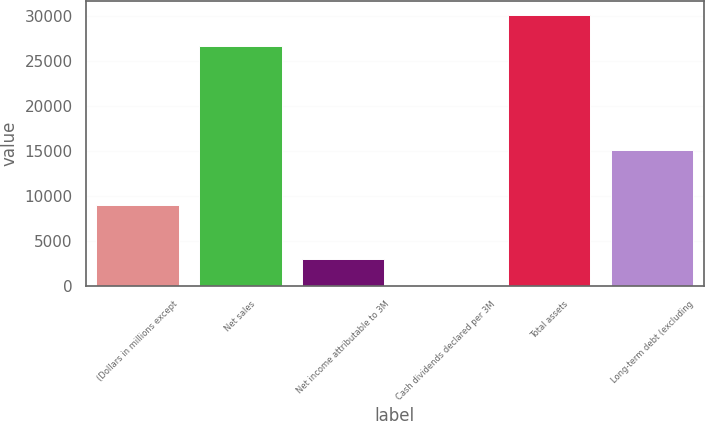<chart> <loc_0><loc_0><loc_500><loc_500><bar_chart><fcel>(Dollars in millions except<fcel>Net sales<fcel>Net income attributable to 3M<fcel>Cash dividends declared per 3M<fcel>Total assets<fcel>Long-term debt (excluding<nl><fcel>9048.27<fcel>26662<fcel>3017.49<fcel>2.1<fcel>30156<fcel>15079<nl></chart> 